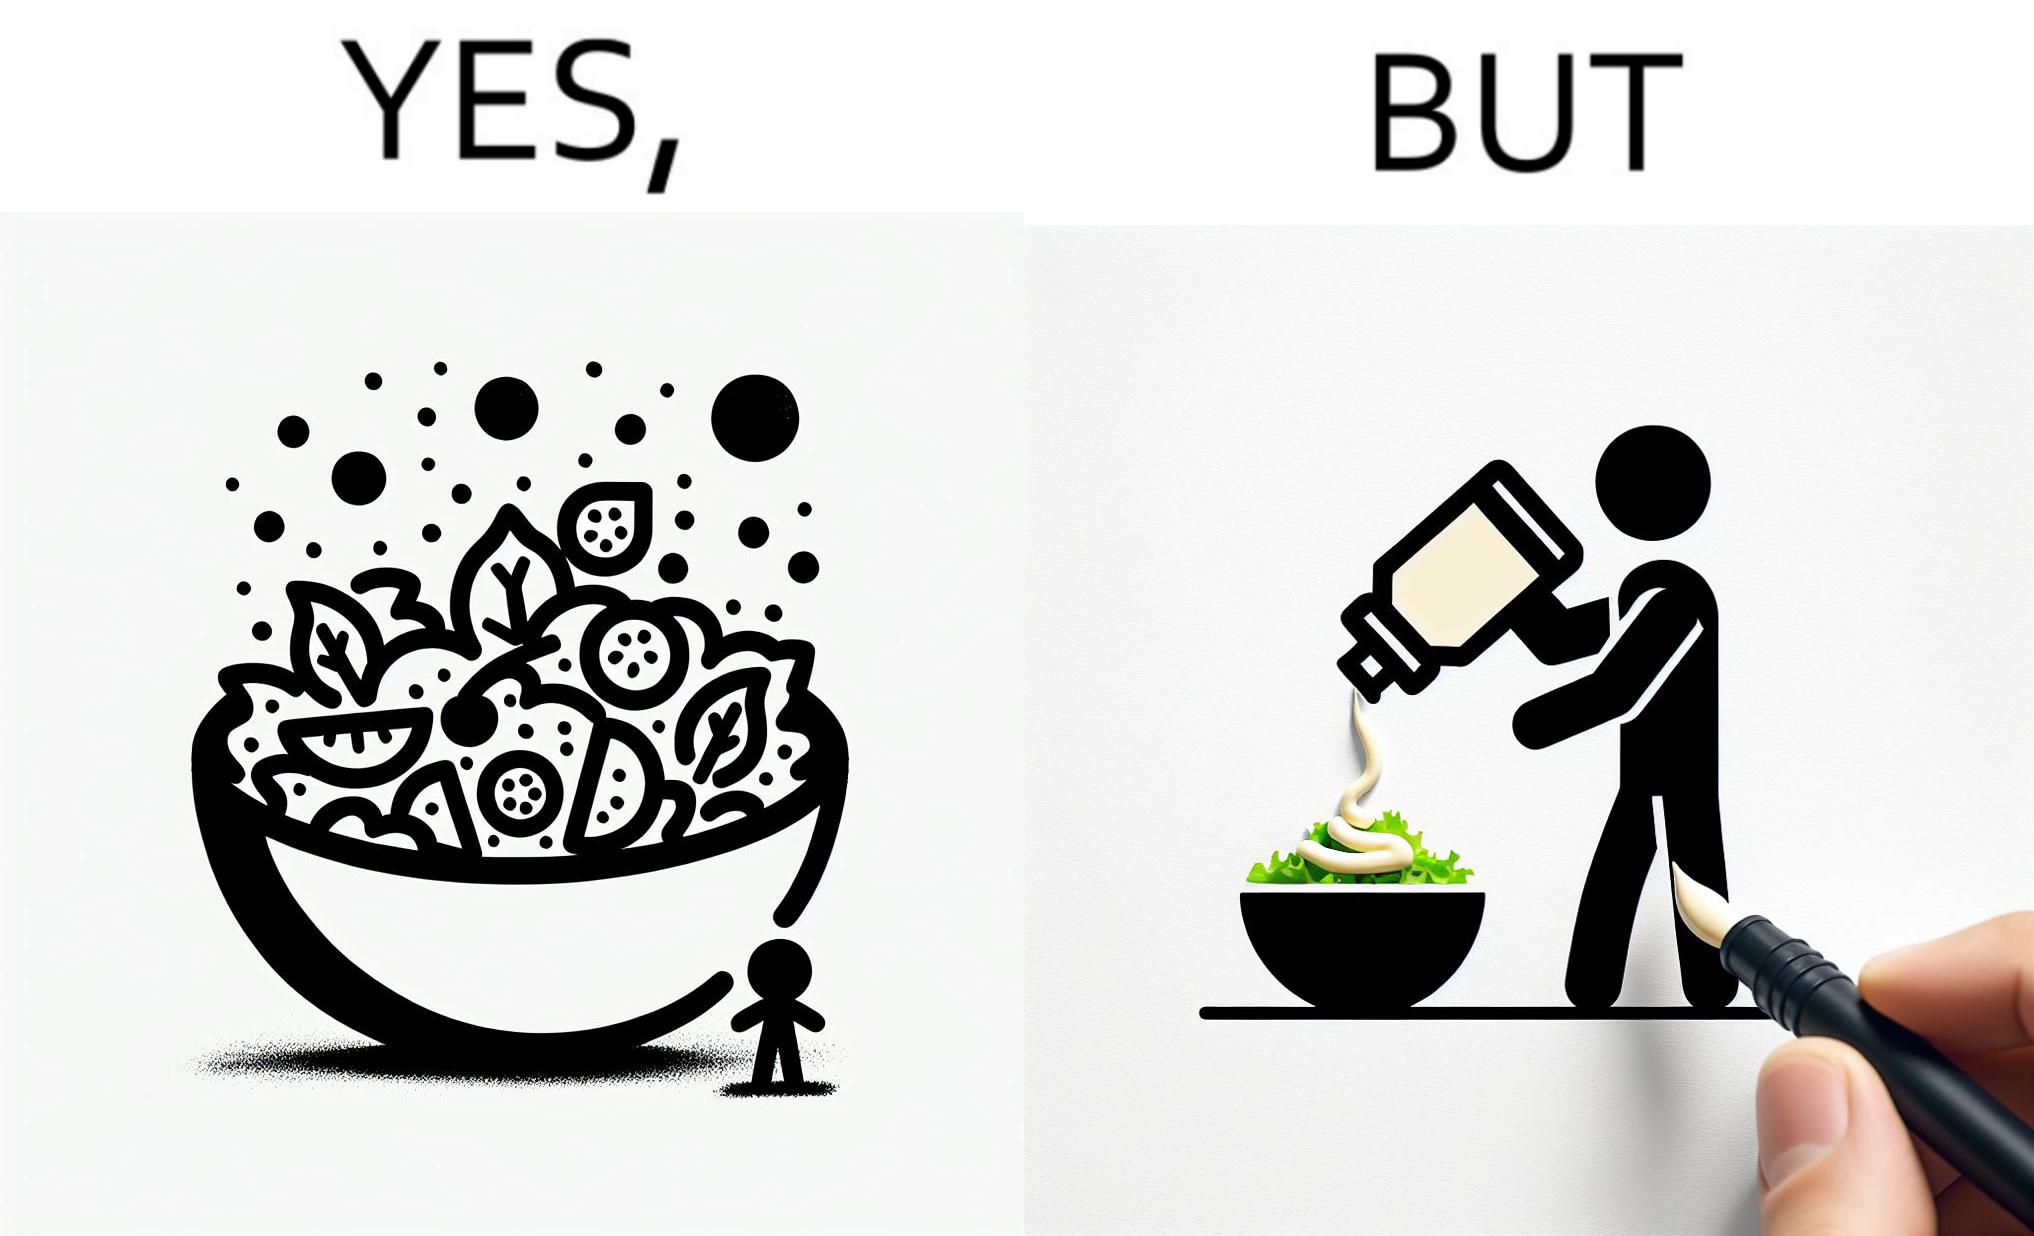Is there satirical content in this image? Yes, this image is satirical. 